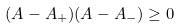Convert formula to latex. <formula><loc_0><loc_0><loc_500><loc_500>( A - A _ { + } ) ( A - A _ { - } ) \geq 0</formula> 